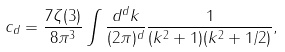Convert formula to latex. <formula><loc_0><loc_0><loc_500><loc_500>c _ { d } = \frac { 7 \zeta ( 3 ) } { 8 \pi ^ { 3 } } \int \frac { d ^ { d } k } { ( 2 \pi ) ^ { d } } \frac { 1 } { ( k ^ { 2 } + 1 ) ( k ^ { 2 } + 1 / 2 ) } ,</formula> 